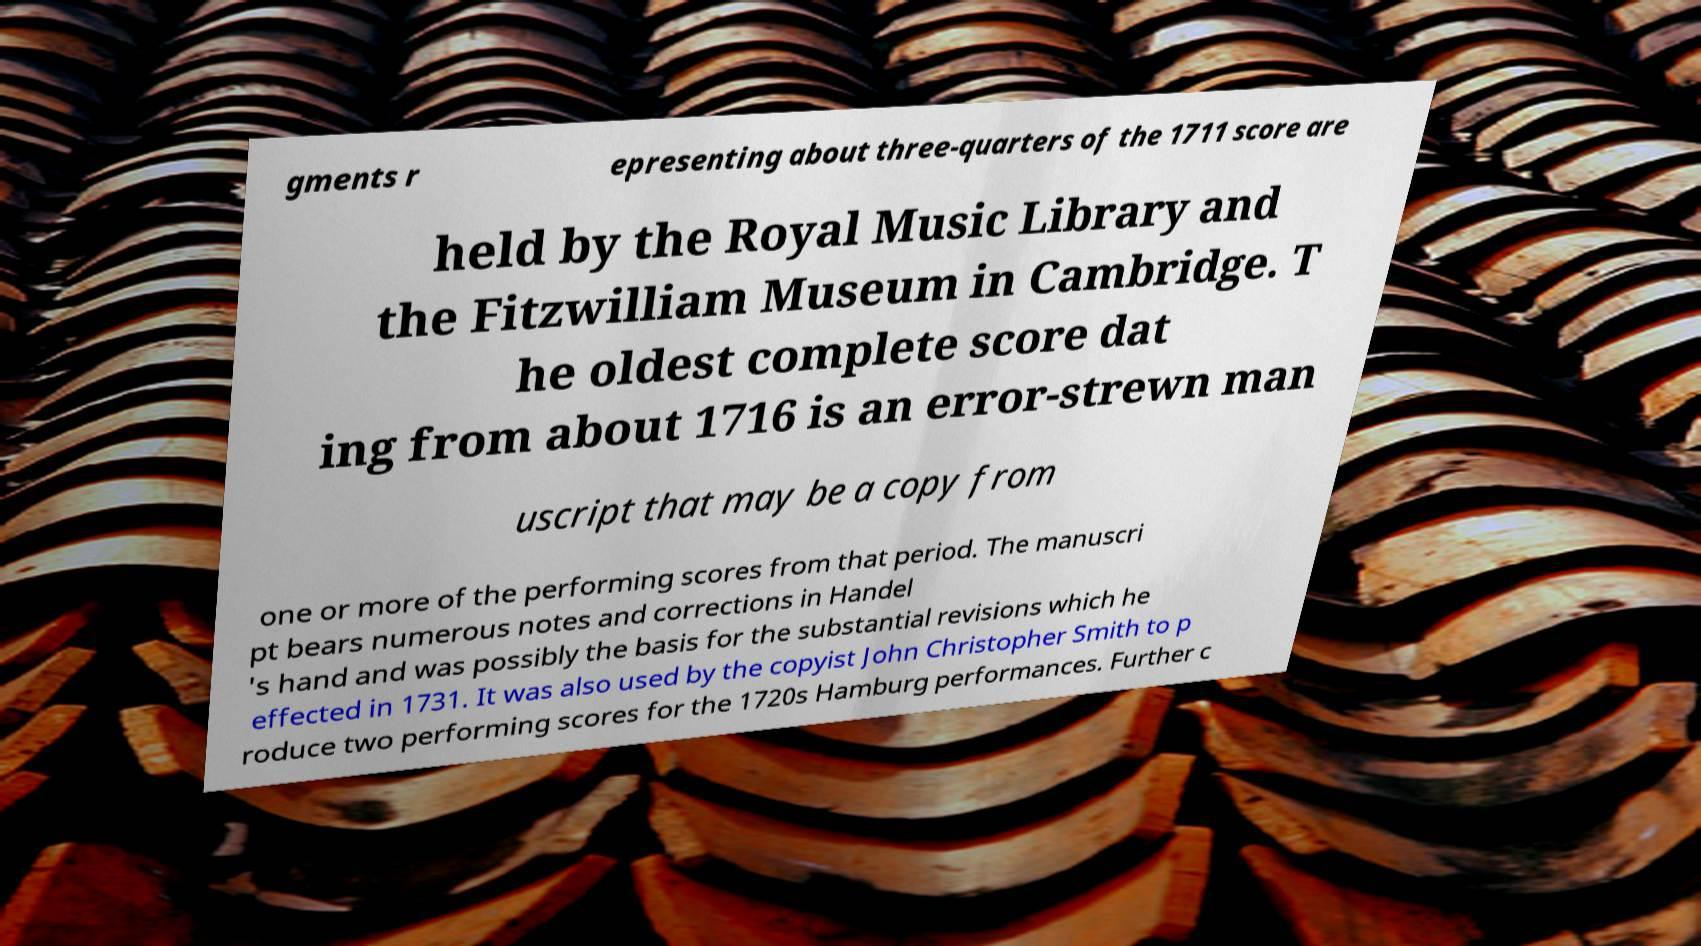Can you accurately transcribe the text from the provided image for me? gments r epresenting about three-quarters of the 1711 score are held by the Royal Music Library and the Fitzwilliam Museum in Cambridge. T he oldest complete score dat ing from about 1716 is an error-strewn man uscript that may be a copy from one or more of the performing scores from that period. The manuscri pt bears numerous notes and corrections in Handel 's hand and was possibly the basis for the substantial revisions which he effected in 1731. It was also used by the copyist John Christopher Smith to p roduce two performing scores for the 1720s Hamburg performances. Further c 